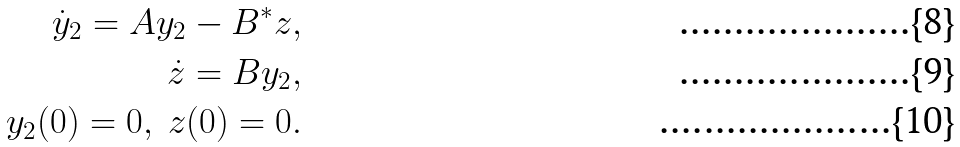Convert formula to latex. <formula><loc_0><loc_0><loc_500><loc_500>\dot { y } _ { 2 } = A y _ { 2 } - B ^ { * } z , \\ \dot { z } = B y _ { 2 } , \\ y _ { 2 } ( 0 ) = 0 , \ z ( 0 ) = 0 .</formula> 